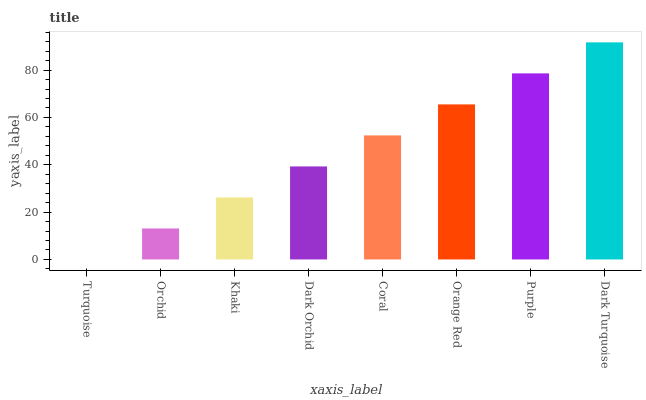Is Turquoise the minimum?
Answer yes or no. Yes. Is Dark Turquoise the maximum?
Answer yes or no. Yes. Is Orchid the minimum?
Answer yes or no. No. Is Orchid the maximum?
Answer yes or no. No. Is Orchid greater than Turquoise?
Answer yes or no. Yes. Is Turquoise less than Orchid?
Answer yes or no. Yes. Is Turquoise greater than Orchid?
Answer yes or no. No. Is Orchid less than Turquoise?
Answer yes or no. No. Is Coral the high median?
Answer yes or no. Yes. Is Dark Orchid the low median?
Answer yes or no. Yes. Is Khaki the high median?
Answer yes or no. No. Is Khaki the low median?
Answer yes or no. No. 